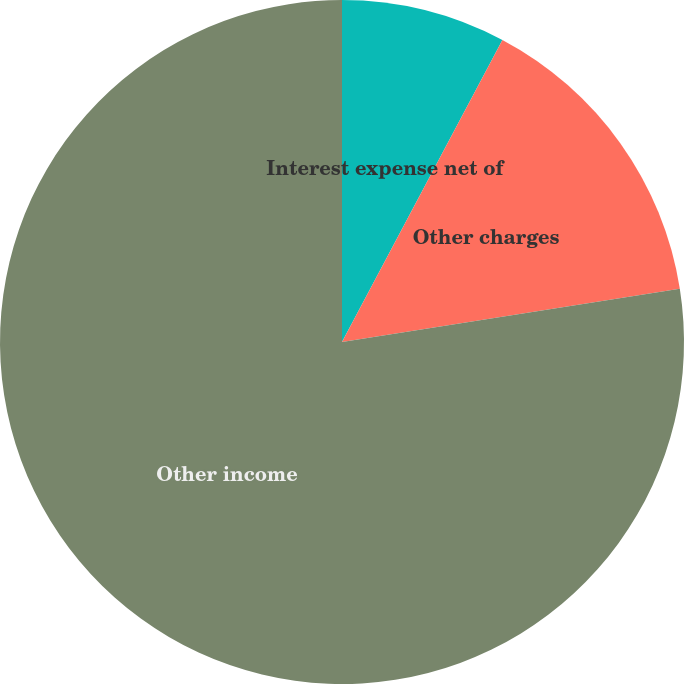Convert chart to OTSL. <chart><loc_0><loc_0><loc_500><loc_500><pie_chart><fcel>Interest expense net of<fcel>Other charges<fcel>Other income<nl><fcel>7.77%<fcel>14.74%<fcel>77.49%<nl></chart> 